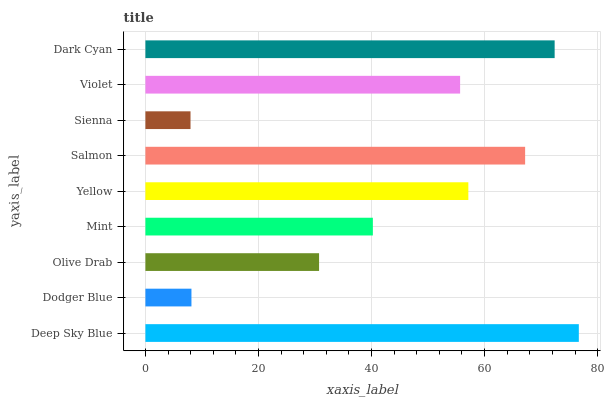Is Sienna the minimum?
Answer yes or no. Yes. Is Deep Sky Blue the maximum?
Answer yes or no. Yes. Is Dodger Blue the minimum?
Answer yes or no. No. Is Dodger Blue the maximum?
Answer yes or no. No. Is Deep Sky Blue greater than Dodger Blue?
Answer yes or no. Yes. Is Dodger Blue less than Deep Sky Blue?
Answer yes or no. Yes. Is Dodger Blue greater than Deep Sky Blue?
Answer yes or no. No. Is Deep Sky Blue less than Dodger Blue?
Answer yes or no. No. Is Violet the high median?
Answer yes or no. Yes. Is Violet the low median?
Answer yes or no. Yes. Is Sienna the high median?
Answer yes or no. No. Is Olive Drab the low median?
Answer yes or no. No. 